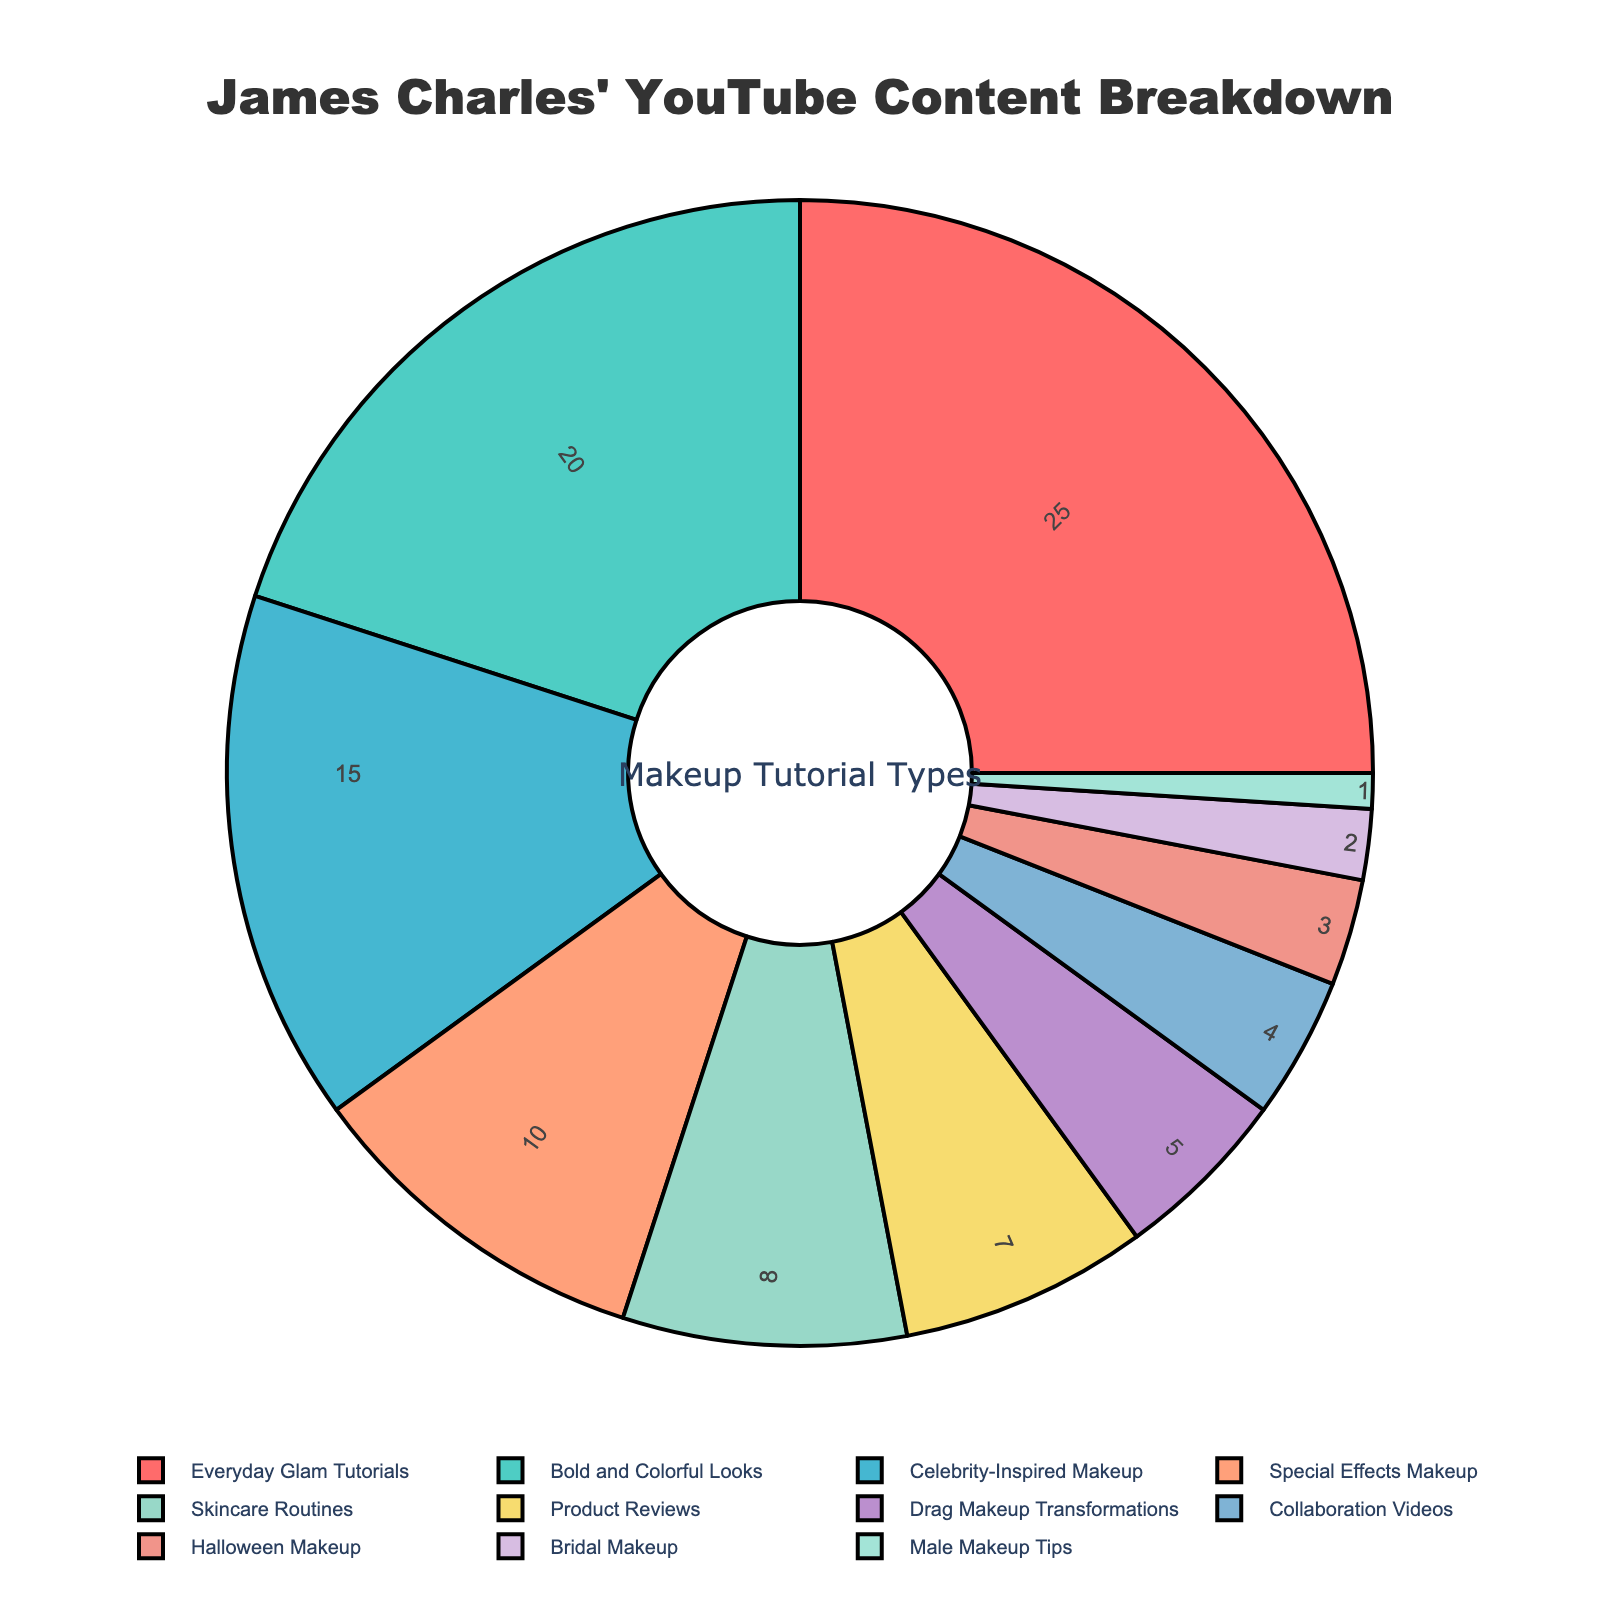What percentage of James Charles' YouTube content consists of Bold and Colorful Looks and Skincare Routines combined? Add the percentages of Bold and Colorful Looks (20%) and Skincare Routines (8%). 20% + 8% = 28%
Answer: 28% Which type of makeup tutorial has the largest share in James Charles' content? Identify the category with the highest percentage, which is Everyday Glam Tutorials at 25%.
Answer: Everyday Glam Tutorials How much larger is the percentage of Celebrity-Inspired Makeup compared to Halloween Makeup? Subtract the percentage of Halloween Makeup (3%) from Celebrity-Inspired Makeup (15%). 15% - 3% = 12%
Answer: 12% Do Drag Makeup Transformations make up more or less than half of the Special Effects Makeup content? Compare 5% for Drag Makeup Transformations with half of 10% for Special Effects Makeup. Half of 10% is 5%, so they are equal.
Answer: Equal How does the percentage of Product Reviews compare to Collaboration Videos? Compare the percentages directly, with Product Reviews at 7% and Collaboration Videos at 4%. 7% is larger than 4%.
Answer: Product Reviews What is the combined percentage of content related to both Everyday Glam Tutorials and Product Reviews? Add the percentage of Everyday Glam Tutorials (25%) and Product Reviews (7%). 25% + 7% = 32%
Answer: 32% Which three types of makeup tutorials have the smallest percentages, and what are their values? Identify the three smallest categories: Male Makeup Tips (1%), Bridal Makeup (2%), and Halloween Makeup (3%).
Answer: Male Makeup Tips (1%), Bridal Makeup (2%), Halloween Makeup (3%) How many times larger is the percentage of Everyday Glam Tutorials compared to Male Makeup Tips? Divide the percentage of Everyday Glam Tutorials (25%) by Male Makeup Tips (1%). 25% / 1% = 25 times larger
Answer: 25 times larger What percentage of James Charles' YouTube content is dedicated to Drag Makeup Transformations and collaboration videos combined? Add the percentages of Drag Makeup Transformations (5%) and Collaboration Videos (4%). 5% + 4% = 9%
Answer: 9% How much more percentage is devoted to Skincare Routines than Halloween Makeup? Subtract the percentage of Halloween Makeup (3%) from Skincare Routines (8%). 8% - 3% = 5%
Answer: 5% 